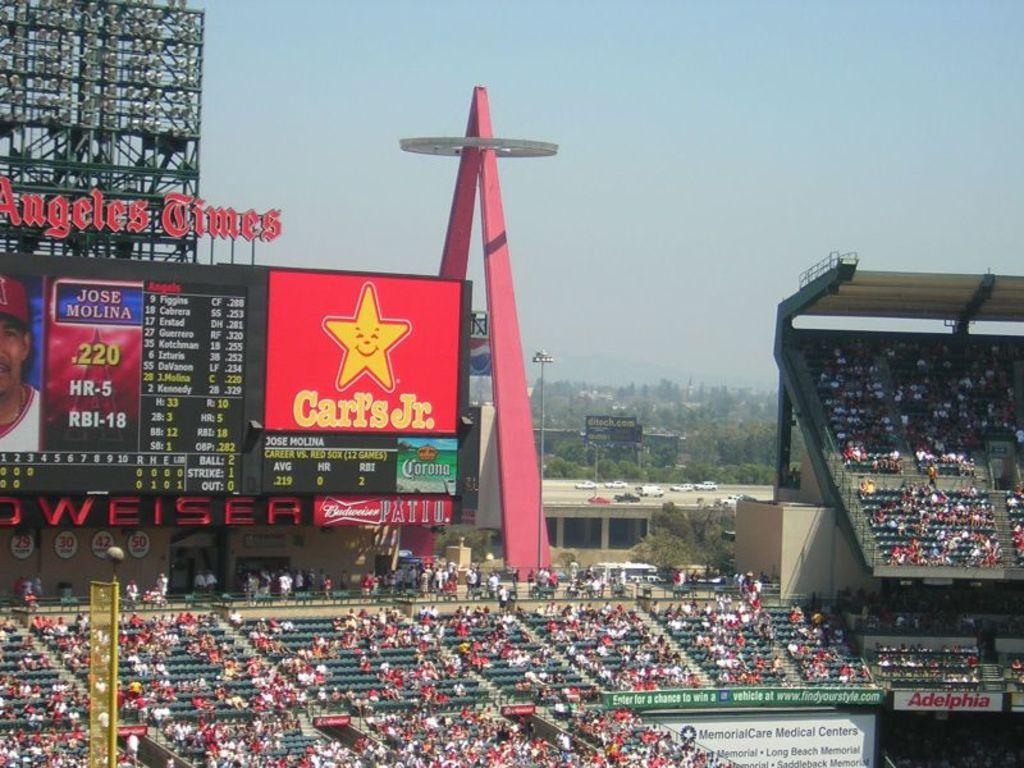<image>
Share a concise interpretation of the image provided. a sports arena with Carl's Jr., and Budweiser advertised in the background. 